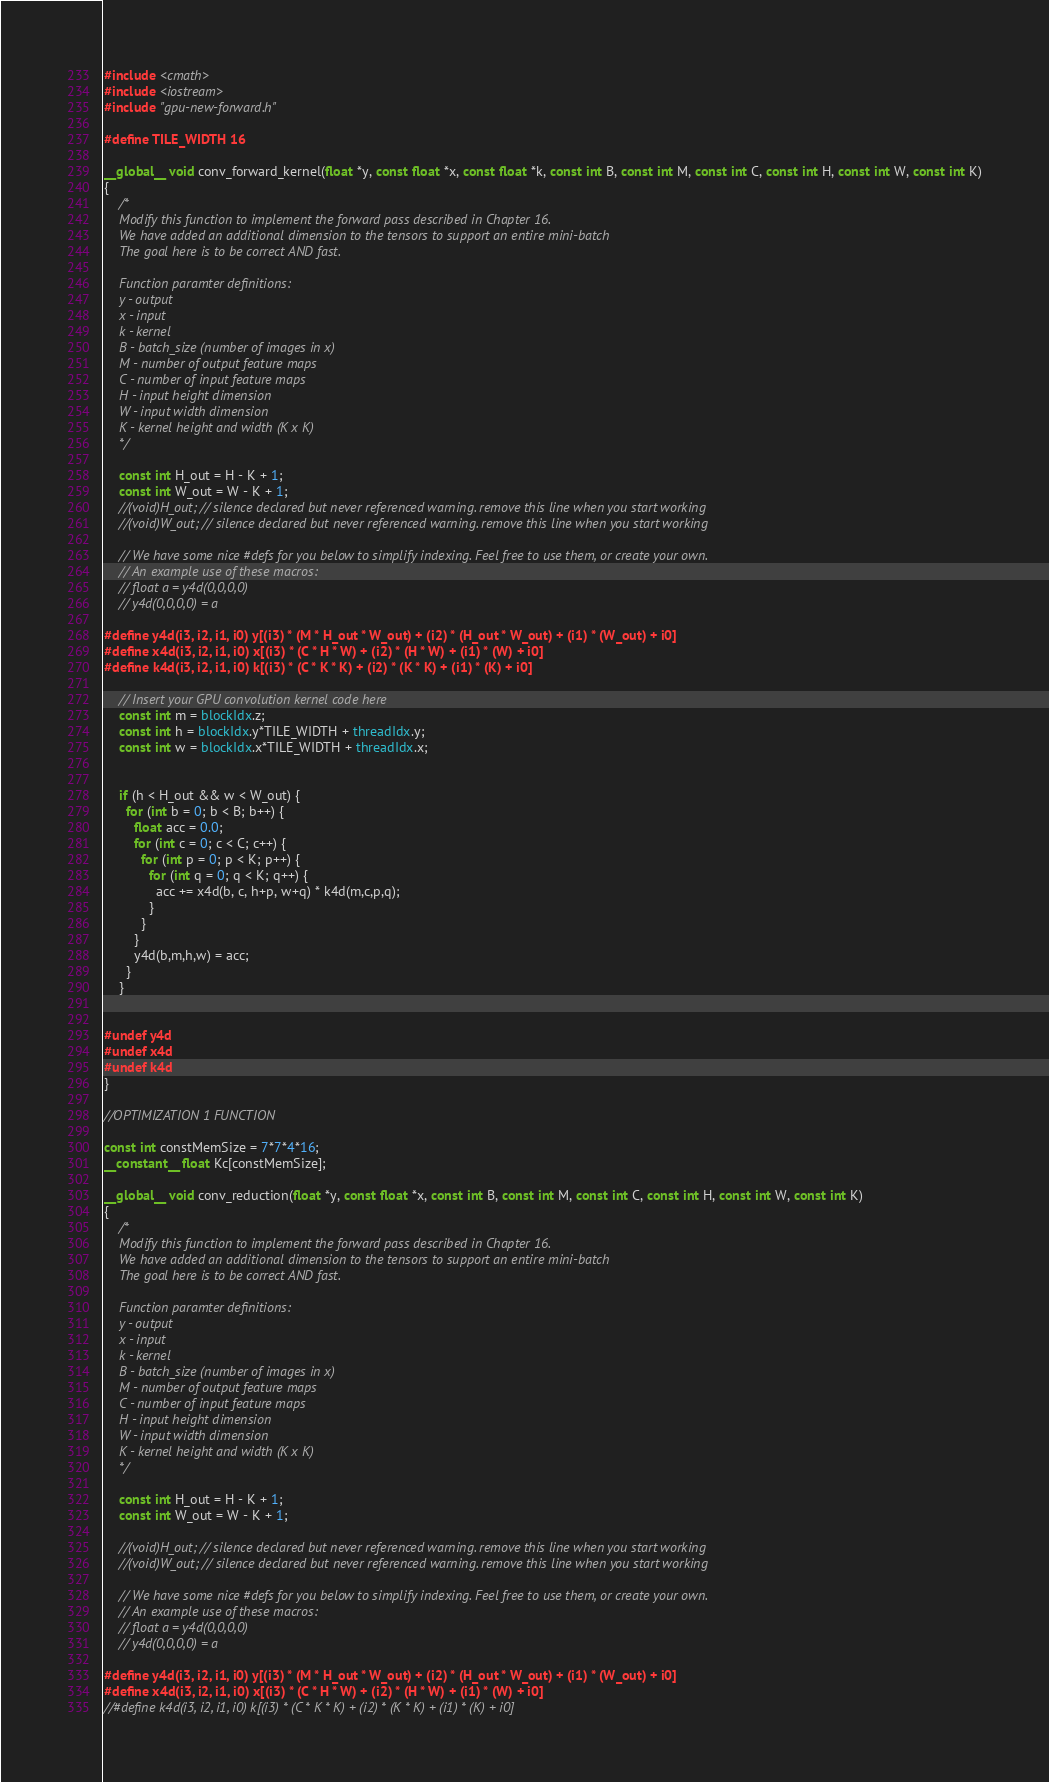Convert code to text. <code><loc_0><loc_0><loc_500><loc_500><_Cuda_>#include <cmath>
#include <iostream>
#include "gpu-new-forward.h"

#define TILE_WIDTH 16

__global__ void conv_forward_kernel(float *y, const float *x, const float *k, const int B, const int M, const int C, const int H, const int W, const int K)
{
    /*
    Modify this function to implement the forward pass described in Chapter 16.
    We have added an additional dimension to the tensors to support an entire mini-batch
    The goal here is to be correct AND fast.

    Function paramter definitions:
    y - output
    x - input
    k - kernel
    B - batch_size (number of images in x)
    M - number of output feature maps
    C - number of input feature maps
    H - input height dimension
    W - input width dimension
    K - kernel height and width (K x K)
    */

    const int H_out = H - K + 1;
    const int W_out = W - K + 1;
    //(void)H_out; // silence declared but never referenced warning. remove this line when you start working
    //(void)W_out; // silence declared but never referenced warning. remove this line when you start working

    // We have some nice #defs for you below to simplify indexing. Feel free to use them, or create your own.
    // An example use of these macros:
    // float a = y4d(0,0,0,0)
    // y4d(0,0,0,0) = a

#define y4d(i3, i2, i1, i0) y[(i3) * (M * H_out * W_out) + (i2) * (H_out * W_out) + (i1) * (W_out) + i0]
#define x4d(i3, i2, i1, i0) x[(i3) * (C * H * W) + (i2) * (H * W) + (i1) * (W) + i0]
#define k4d(i3, i2, i1, i0) k[(i3) * (C * K * K) + (i2) * (K * K) + (i1) * (K) + i0]

    // Insert your GPU convolution kernel code here
    const int m = blockIdx.z;
    const int h = blockIdx.y*TILE_WIDTH + threadIdx.y;
    const int w = blockIdx.x*TILE_WIDTH + threadIdx.x;


    if (h < H_out && w < W_out) {
      for (int b = 0; b < B; b++) {
        float acc = 0.0;
        for (int c = 0; c < C; c++) {
          for (int p = 0; p < K; p++) {
            for (int q = 0; q < K; q++) {
              acc += x4d(b, c, h+p, w+q) * k4d(m,c,p,q);
            }
          }
        }
        y4d(b,m,h,w) = acc;
      }
    }


#undef y4d
#undef x4d
#undef k4d
}

//OPTIMIZATION 1 FUNCTION

const int constMemSize = 7*7*4*16;
__constant__ float Kc[constMemSize];

__global__ void conv_reduction(float *y, const float *x, const int B, const int M, const int C, const int H, const int W, const int K)
{
    /*
    Modify this function to implement the forward pass described in Chapter 16.
    We have added an additional dimension to the tensors to support an entire mini-batch
    The goal here is to be correct AND fast.

    Function paramter definitions:
    y - output
    x - input
    k - kernel
    B - batch_size (number of images in x)
    M - number of output feature maps
    C - number of input feature maps
    H - input height dimension
    W - input width dimension
    K - kernel height and width (K x K)
    */

    const int H_out = H - K + 1;
    const int W_out = W - K + 1;

    //(void)H_out; // silence declared but never referenced warning. remove this line when you start working
    //(void)W_out; // silence declared but never referenced warning. remove this line when you start working

    // We have some nice #defs for you below to simplify indexing. Feel free to use them, or create your own.
    // An example use of these macros:
    // float a = y4d(0,0,0,0)
    // y4d(0,0,0,0) = a

#define y4d(i3, i2, i1, i0) y[(i3) * (M * H_out * W_out) + (i2) * (H_out * W_out) + (i1) * (W_out) + i0]
#define x4d(i3, i2, i1, i0) x[(i3) * (C * H * W) + (i2) * (H * W) + (i1) * (W) + i0]
//#define k4d(i3, i2, i1, i0) k[(i3) * (C * K * K) + (i2) * (K * K) + (i1) * (K) + i0]</code> 